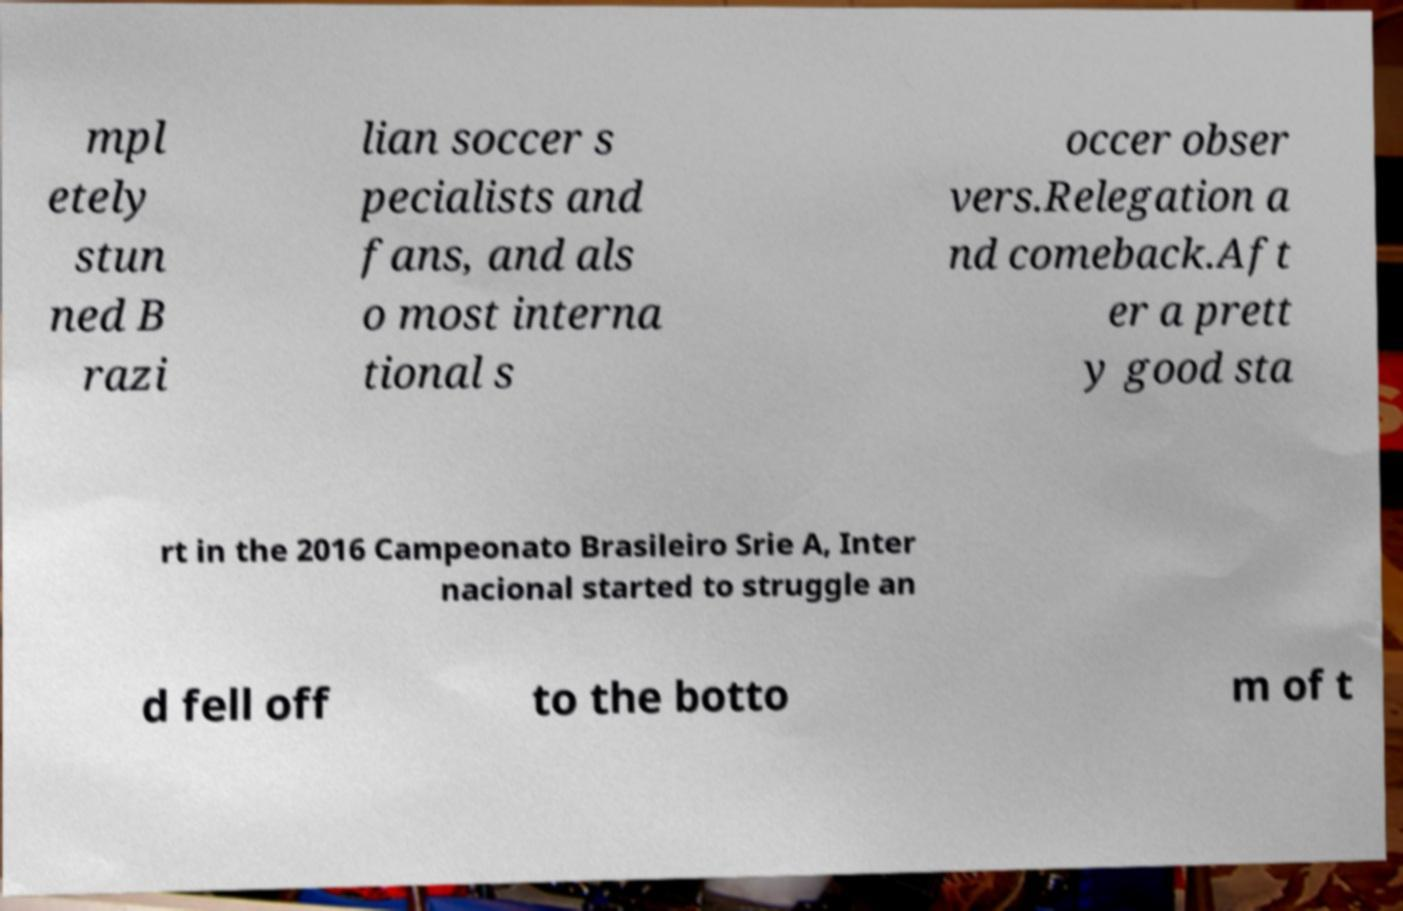What messages or text are displayed in this image? I need them in a readable, typed format. mpl etely stun ned B razi lian soccer s pecialists and fans, and als o most interna tional s occer obser vers.Relegation a nd comeback.Aft er a prett y good sta rt in the 2016 Campeonato Brasileiro Srie A, Inter nacional started to struggle an d fell off to the botto m of t 